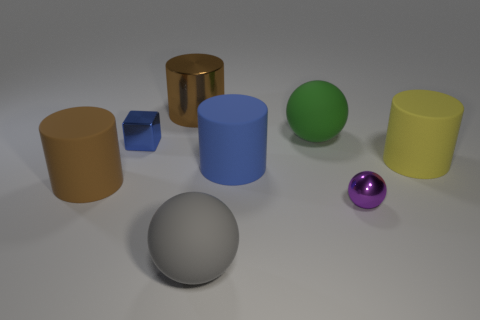What color is the metallic cylinder that is the same size as the gray rubber sphere?
Provide a succinct answer. Brown. Are there fewer yellow cylinders that are behind the yellow cylinder than small blue cubes that are in front of the small metallic block?
Your response must be concise. No. There is a matte thing that is on the left side of the blue metallic object; does it have the same size as the small purple thing?
Give a very brief answer. No. The metal object that is on the left side of the big metal object has what shape?
Give a very brief answer. Cube. Is the number of brown objects greater than the number of tiny red spheres?
Ensure brevity in your answer.  Yes. There is a large rubber ball behind the big blue cylinder; does it have the same color as the shiny cylinder?
Ensure brevity in your answer.  No. What number of things are things that are to the right of the green rubber object or rubber cylinders on the left side of the brown shiny cylinder?
Your answer should be compact. 3. How many things are both behind the big blue matte cylinder and left of the big green matte ball?
Provide a succinct answer. 2. Are the large yellow object and the blue cube made of the same material?
Your answer should be compact. No. What is the shape of the purple thing that is in front of the big object behind the large rubber sphere behind the block?
Keep it short and to the point. Sphere. 